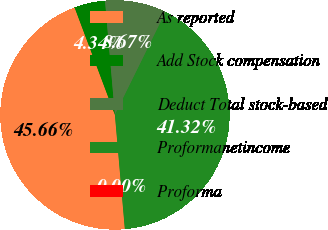Convert chart. <chart><loc_0><loc_0><loc_500><loc_500><pie_chart><fcel>As reported<fcel>Add Stock compensation<fcel>Deduct Total stock-based<fcel>Proformanetincome<fcel>Proforma<nl><fcel>45.66%<fcel>4.34%<fcel>8.67%<fcel>41.32%<fcel>0.0%<nl></chart> 